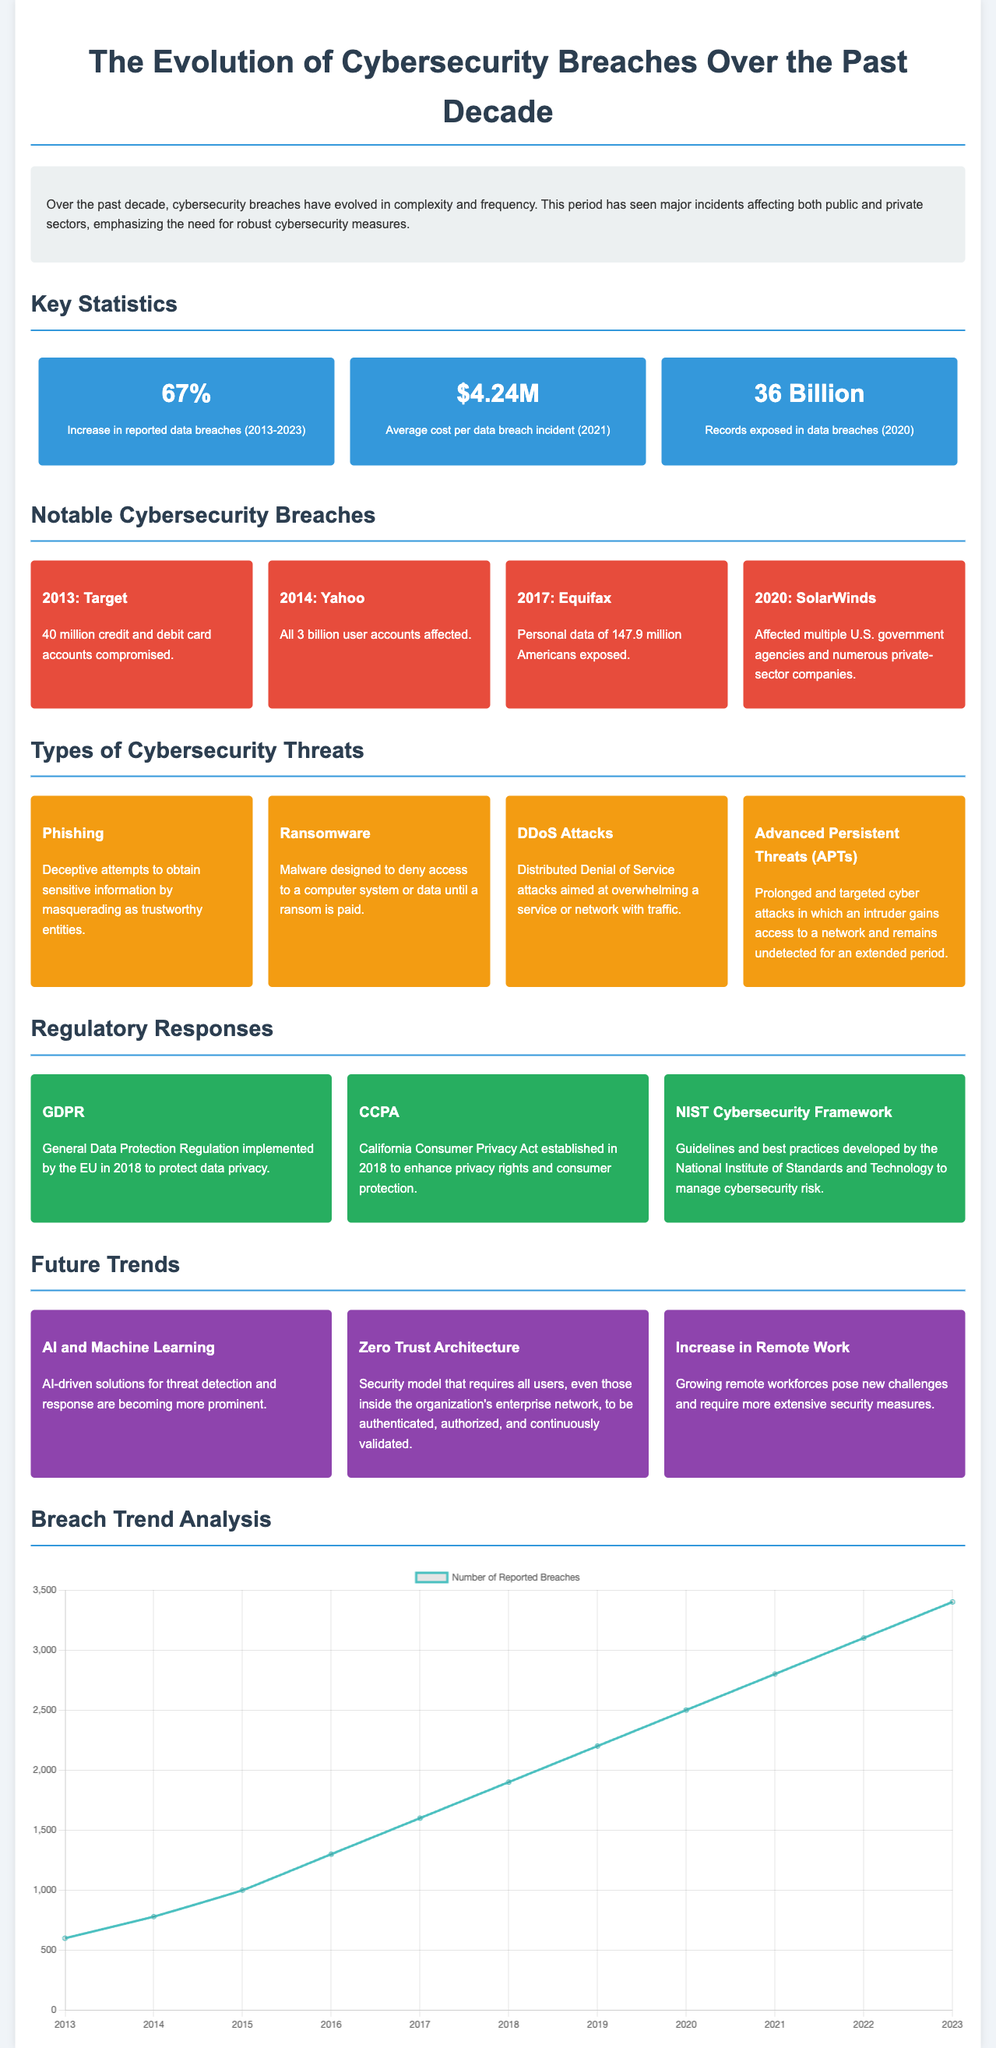What was the percentage increase in reported data breaches from 2013 to 2023? The document states a 67% increase in reported data breaches over this period.
Answer: 67% What was the average cost per data breach incident in 2021? The average cost per data breach incident reported in 2021 was $4.24 million.
Answer: $4.24M What major cybersecurity incident occurred in 2014? The document mentions Yahoo as the notable breach in 2014 where all 3 billion user accounts were affected.
Answer: Yahoo Which threat is described as deceptive attempts to obtain sensitive information? The infographic describes phishing as deceptive attempts to obtain sensitive information.
Answer: Phishing What cybersecurity regulation was implemented by the EU in 2018? GDPR, or General Data Protection Regulation, was implemented by the EU in 2018 to protect data privacy.
Answer: GDPR How many records were exposed in data breaches in 2020? The document states that 36 billion records were exposed in data breaches in 2020.
Answer: 36 billion What is one future trend mentioned that relates to workforce security? The document lists the increase in remote work as a future trend posing new security challenges.
Answer: Increase in Remote Work What year did the number of reported breaches exceed 3000? According to the chart, the number of reported breaches exceeded 3000 in 2022.
Answer: 2022 Which type of threat involves overwhelming a service with traffic? The document categorizes DDoS attacks as threats aimed at overwhelming a service with traffic.
Answer: DDoS Attacks 